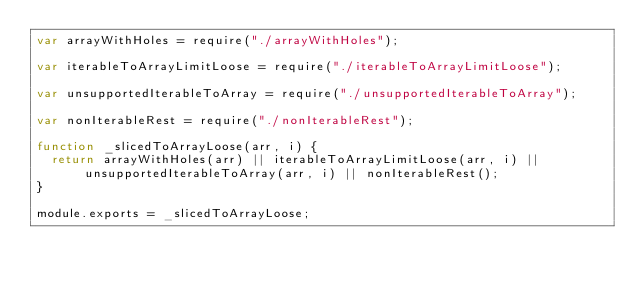Convert code to text. <code><loc_0><loc_0><loc_500><loc_500><_JavaScript_>var arrayWithHoles = require("./arrayWithHoles");

var iterableToArrayLimitLoose = require("./iterableToArrayLimitLoose");

var unsupportedIterableToArray = require("./unsupportedIterableToArray");

var nonIterableRest = require("./nonIterableRest");

function _slicedToArrayLoose(arr, i) {
  return arrayWithHoles(arr) || iterableToArrayLimitLoose(arr, i) || unsupportedIterableToArray(arr, i) || nonIterableRest();
}

module.exports = _slicedToArrayLoose;</code> 